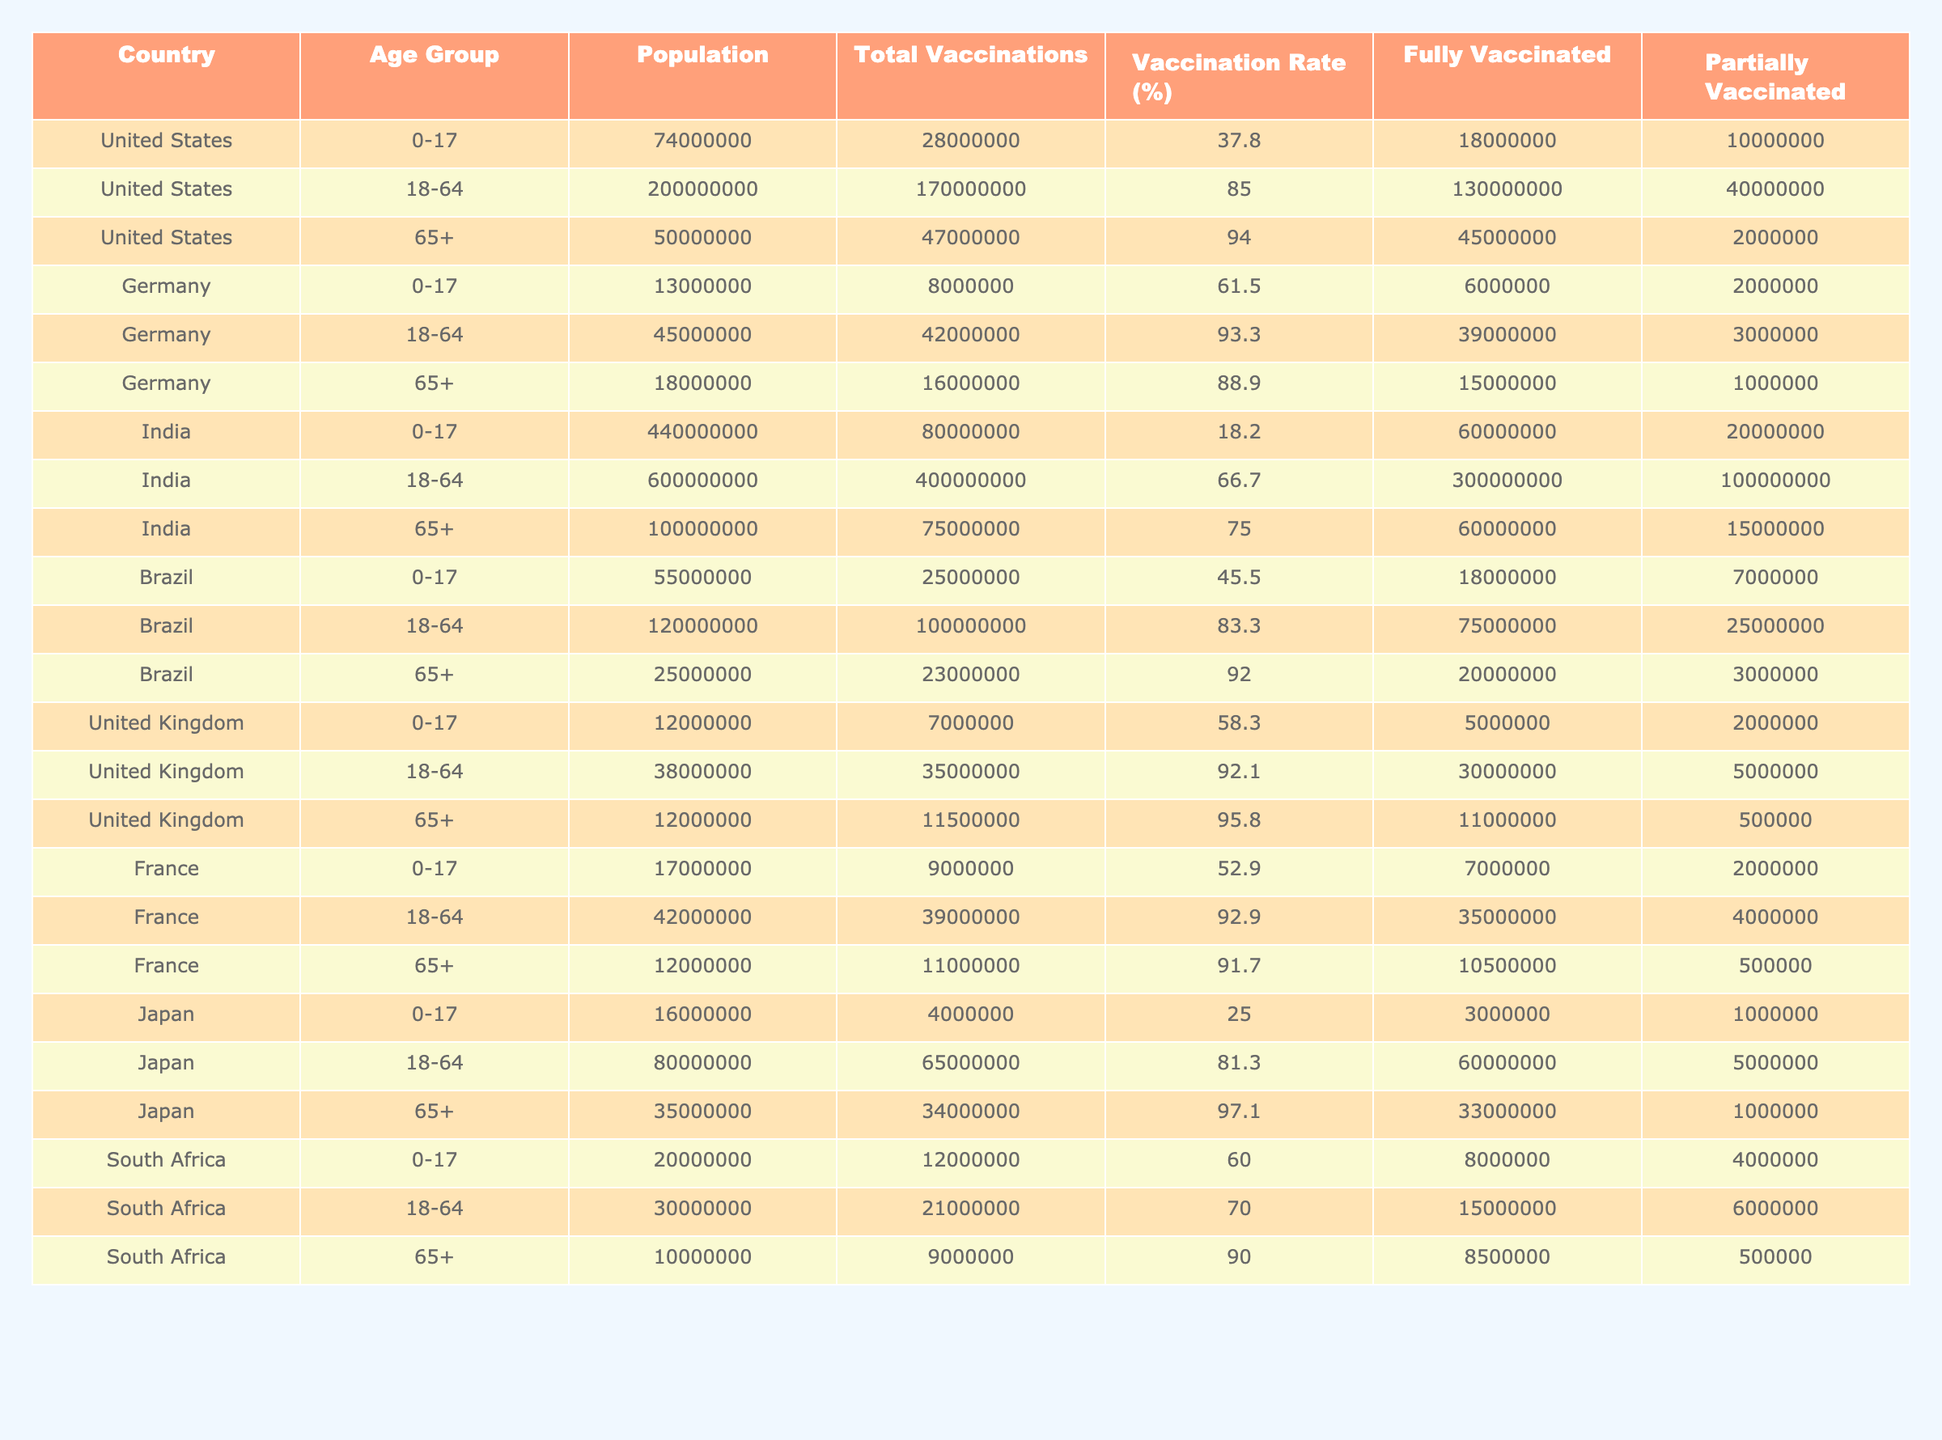What is the vaccination rate for the United States in the 18-64 age group? The table shows that the vaccination rate for the United States in the 18-64 age group is listed as 85.0%.
Answer: 85.0% Which country has the highest fully vaccinated population in the 65+ age group? By comparing the fully vaccinated numbers in the 65+ age group, the United States has 45,000,000 fully vaccinated individuals, which is the highest among the listed countries.
Answer: United States What is the total number of vaccinations given to the 0-17 age group in Germany? The table indicates that Germany has administered a total of 8,000,000 vaccinations to the 0-17 age group.
Answer: 8,000,000 Is the vaccination rate in India for the 0-17 age group less than 20%? The table shows that India's vaccination rate for the 0-17 age group is 18.2%, which is indeed less than 20%.
Answer: Yes How many partially vaccinated individuals are there in Brazil for the 18-64 age group compared to the 65+ age group? In the 18-64 age group, Brazil has 25,000,000 partially vaccinated individuals; in the 65+ age group, there are 3,000,000. The difference is 25,000,000 - 3,000,000 = 22,000,000.
Answer: 22,000,000 What percentage of South Africa's 65+ age group is fully vaccinated? South Africa has 8,500,000 fully vaccinated individuals in the 65+ age group out of a total vaccinated population of 9,000,000. The percentage is (8,500,000 / 9,000,000) * 100 = 94.4%.
Answer: 94.4% Which country has a higher vaccination rate for 0-17 age group: United Kingdom or France? The United Kingdom has a vaccination rate of 58.3% for the 0-17 age group, while France's rate is 52.9%. Comparing these, the U.K. has a higher rate.
Answer: United Kingdom What is the combined total number of vaccinations for the 18-64 age groups across all countries? By summing the vaccination totals for 18-64 age groups: United States (170,000,000) + Germany (42,000,000) + India (400,000,000) + Brazil (100,000,000) + United Kingdom (35,000,000) + France (39,000,000) + Japan (65,000,000) + South Africa (21,000,000) gives us a total of 900,000,000 vaccinations.
Answer: 900,000,000 In which country do the 65+ age group have the lowest vaccination rate? By examining the data, India has a vaccination rate of 75.0% for the 65+ age group, which is the lowest compared to the other countries.
Answer: India What is the average vaccination rate across all the countries in the 18-64 age group? The rates for the 18-64 age groups are: 85.0% (United States), 93.3% (Germany), 66.7% (India), 83.3% (Brazil), 92.1% (United Kingdom), 92.9% (France), 81.3% (Japan), and 70.0% (South Africa); averaging these gives: (85.0 + 93.3 + 66.7 + 83.3 + 92.1 + 92.9 + 81.3 + 70.0) / 8 = 81.4%.
Answer: 81.4% 